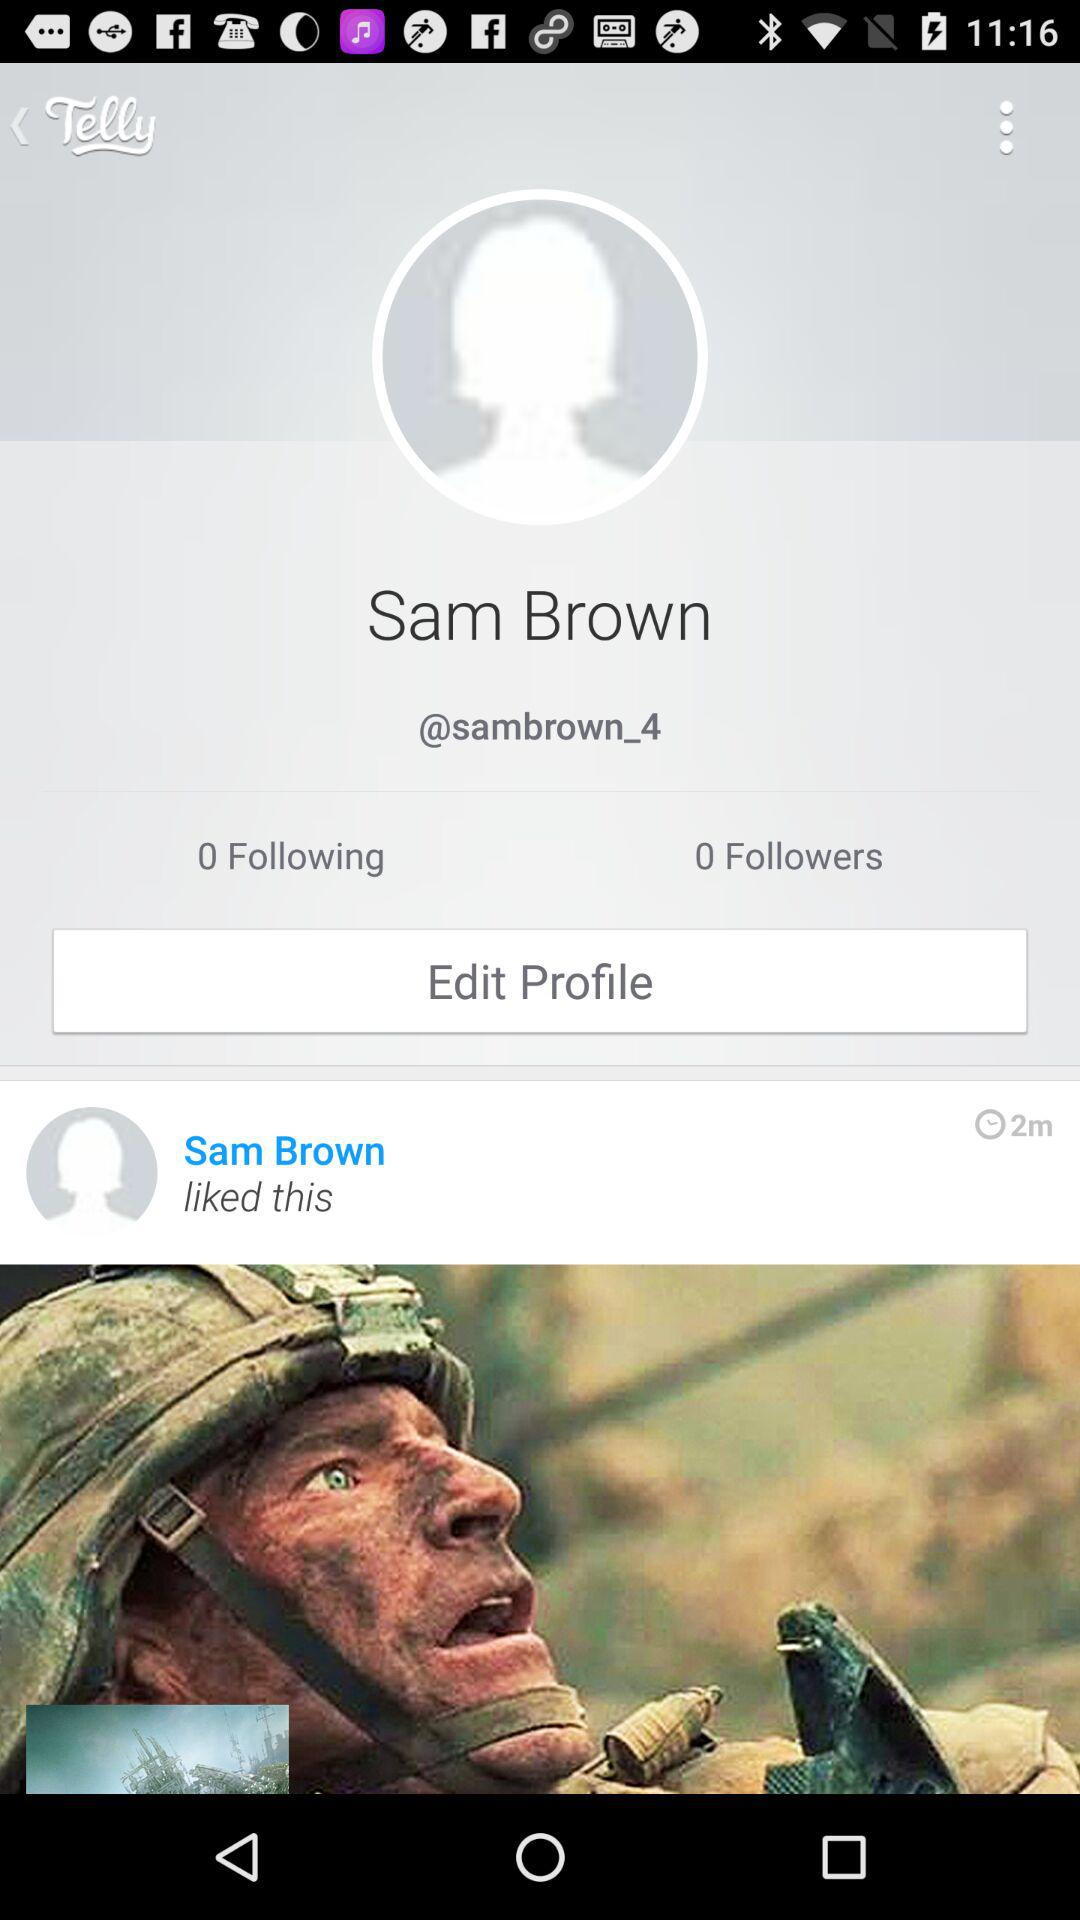How many followers are there? There are 0 followers. 